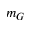<formula> <loc_0><loc_0><loc_500><loc_500>m _ { G }</formula> 